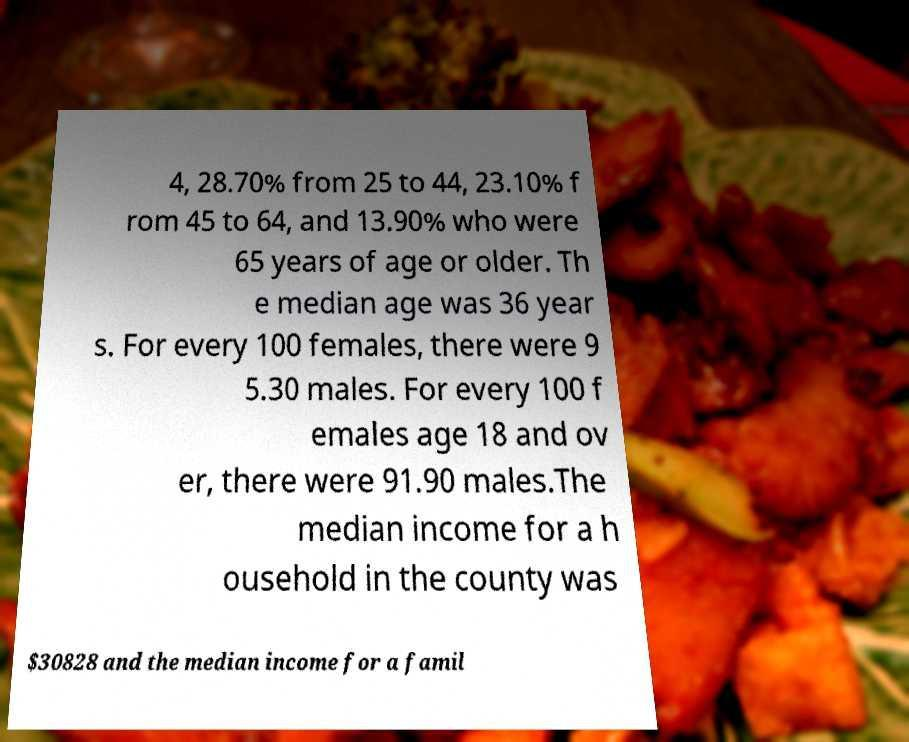Can you accurately transcribe the text from the provided image for me? 4, 28.70% from 25 to 44, 23.10% f rom 45 to 64, and 13.90% who were 65 years of age or older. Th e median age was 36 year s. For every 100 females, there were 9 5.30 males. For every 100 f emales age 18 and ov er, there were 91.90 males.The median income for a h ousehold in the county was $30828 and the median income for a famil 